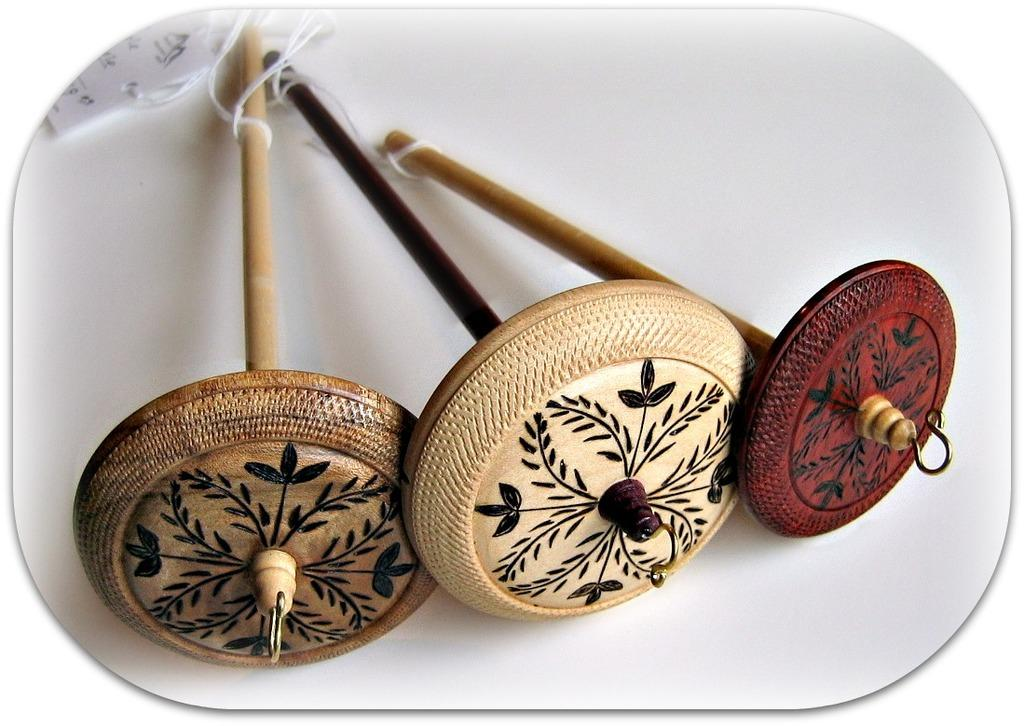What type of material is used for the objects in the image? The objects in the image are made of wood. What is the thin, flexible material visible in the image? There is a thread visible in the image. What additional detail can be seen on the objects? There is a tag in the image. What color is the background of the image? The background of the image is white. How many chickens are present in the image? There are no chickens present in the image. What type of prison is depicted in the image? There is no prison depicted in the image. 